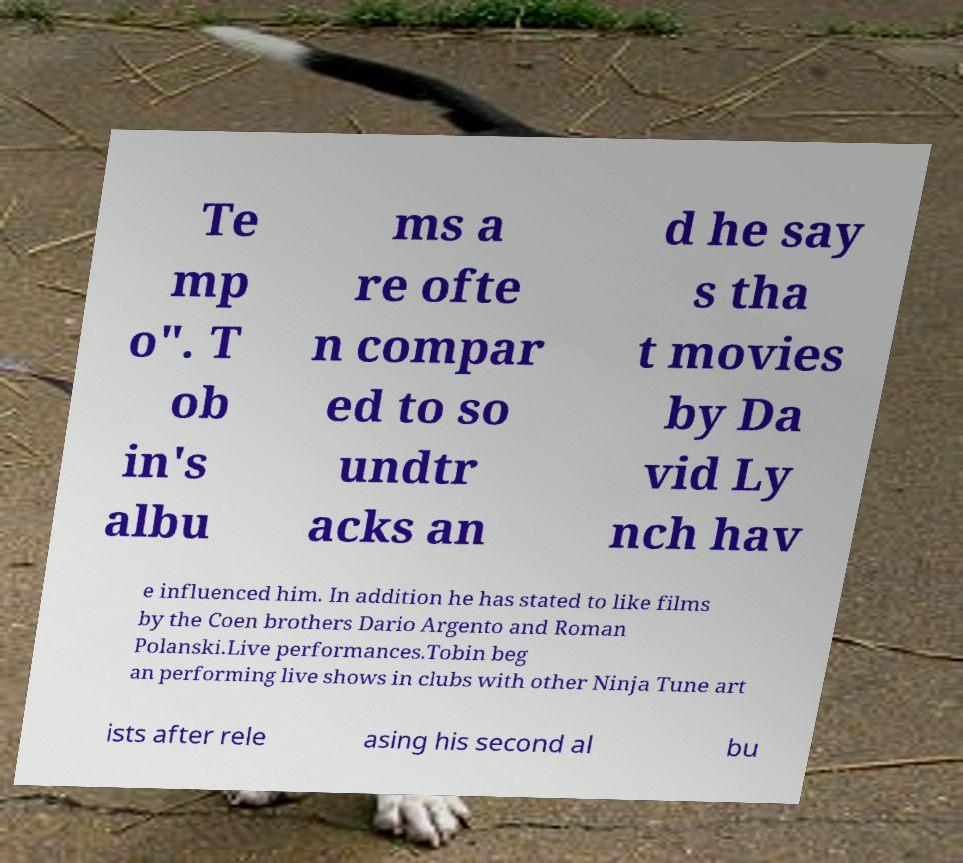I need the written content from this picture converted into text. Can you do that? Te mp o". T ob in's albu ms a re ofte n compar ed to so undtr acks an d he say s tha t movies by Da vid Ly nch hav e influenced him. In addition he has stated to like films by the Coen brothers Dario Argento and Roman Polanski.Live performances.Tobin beg an performing live shows in clubs with other Ninja Tune art ists after rele asing his second al bu 